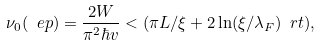<formula> <loc_0><loc_0><loc_500><loc_500>\nu _ { 0 } ( \ e p ) = \frac { 2 W } { \pi ^ { 2 } \hbar { v } } < ( \pi L / \xi + 2 \ln ( \xi / \lambda _ { F } ) \ r t ) ,</formula> 